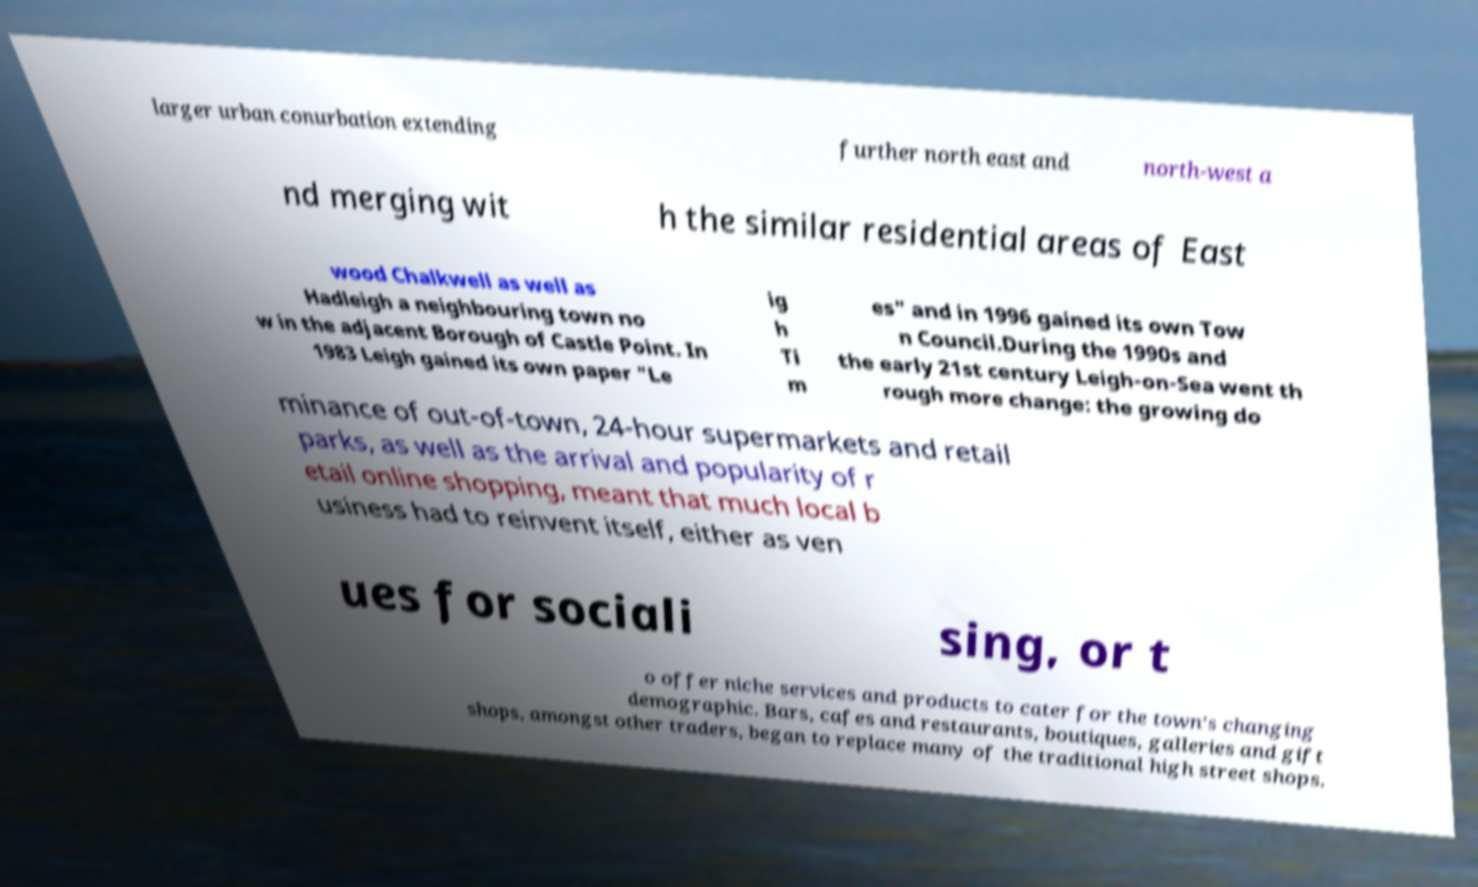What messages or text are displayed in this image? I need them in a readable, typed format. larger urban conurbation extending further north east and north-west a nd merging wit h the similar residential areas of East wood Chalkwell as well as Hadleigh a neighbouring town no w in the adjacent Borough of Castle Point. In 1983 Leigh gained its own paper "Le ig h Ti m es" and in 1996 gained its own Tow n Council.During the 1990s and the early 21st century Leigh-on-Sea went th rough more change: the growing do minance of out-of-town, 24-hour supermarkets and retail parks, as well as the arrival and popularity of r etail online shopping, meant that much local b usiness had to reinvent itself, either as ven ues for sociali sing, or t o offer niche services and products to cater for the town's changing demographic. Bars, cafes and restaurants, boutiques, galleries and gift shops, amongst other traders, began to replace many of the traditional high street shops. 